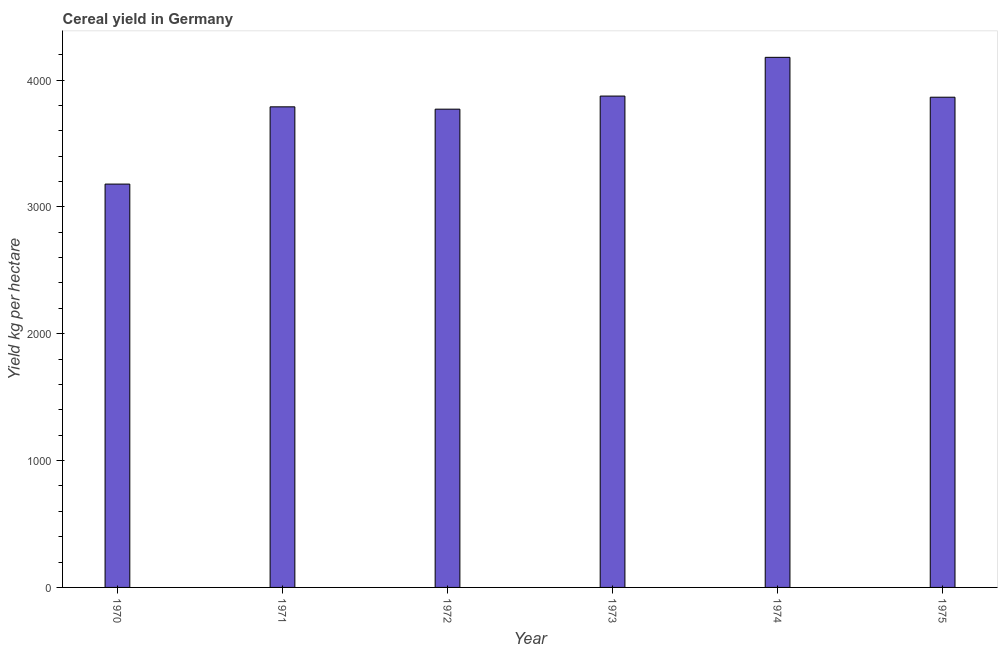Does the graph contain any zero values?
Provide a succinct answer. No. What is the title of the graph?
Give a very brief answer. Cereal yield in Germany. What is the label or title of the Y-axis?
Your answer should be compact. Yield kg per hectare. What is the cereal yield in 1973?
Offer a terse response. 3873.43. Across all years, what is the maximum cereal yield?
Ensure brevity in your answer.  4178.84. Across all years, what is the minimum cereal yield?
Offer a terse response. 3179.65. In which year was the cereal yield maximum?
Make the answer very short. 1974. What is the sum of the cereal yield?
Your answer should be compact. 2.27e+04. What is the difference between the cereal yield in 1972 and 1974?
Your answer should be compact. -408.62. What is the average cereal yield per year?
Offer a very short reply. 3775.86. What is the median cereal yield?
Offer a terse response. 3826.5. In how many years, is the cereal yield greater than 1200 kg per hectare?
Offer a very short reply. 6. Do a majority of the years between 1971 and 1970 (inclusive) have cereal yield greater than 600 kg per hectare?
Ensure brevity in your answer.  No. Is the cereal yield in 1971 less than that in 1975?
Make the answer very short. Yes. Is the difference between the cereal yield in 1970 and 1973 greater than the difference between any two years?
Your response must be concise. No. What is the difference between the highest and the second highest cereal yield?
Give a very brief answer. 305.41. What is the difference between the highest and the lowest cereal yield?
Provide a succinct answer. 999.19. In how many years, is the cereal yield greater than the average cereal yield taken over all years?
Offer a terse response. 4. What is the difference between two consecutive major ticks on the Y-axis?
Make the answer very short. 1000. What is the Yield kg per hectare in 1970?
Provide a succinct answer. 3179.65. What is the Yield kg per hectare in 1971?
Provide a short and direct response. 3788.56. What is the Yield kg per hectare in 1972?
Your answer should be compact. 3770.22. What is the Yield kg per hectare of 1973?
Your answer should be very brief. 3873.43. What is the Yield kg per hectare of 1974?
Keep it short and to the point. 4178.84. What is the Yield kg per hectare in 1975?
Your response must be concise. 3864.43. What is the difference between the Yield kg per hectare in 1970 and 1971?
Ensure brevity in your answer.  -608.91. What is the difference between the Yield kg per hectare in 1970 and 1972?
Your answer should be very brief. -590.57. What is the difference between the Yield kg per hectare in 1970 and 1973?
Your answer should be compact. -693.78. What is the difference between the Yield kg per hectare in 1970 and 1974?
Give a very brief answer. -999.2. What is the difference between the Yield kg per hectare in 1970 and 1975?
Ensure brevity in your answer.  -684.79. What is the difference between the Yield kg per hectare in 1971 and 1972?
Your answer should be very brief. 18.34. What is the difference between the Yield kg per hectare in 1971 and 1973?
Provide a short and direct response. -84.87. What is the difference between the Yield kg per hectare in 1971 and 1974?
Provide a short and direct response. -390.28. What is the difference between the Yield kg per hectare in 1971 and 1975?
Your answer should be very brief. -75.88. What is the difference between the Yield kg per hectare in 1972 and 1973?
Offer a very short reply. -103.21. What is the difference between the Yield kg per hectare in 1972 and 1974?
Your answer should be very brief. -408.62. What is the difference between the Yield kg per hectare in 1972 and 1975?
Offer a terse response. -94.22. What is the difference between the Yield kg per hectare in 1973 and 1974?
Your answer should be compact. -305.41. What is the difference between the Yield kg per hectare in 1973 and 1975?
Keep it short and to the point. 8.99. What is the difference between the Yield kg per hectare in 1974 and 1975?
Offer a very short reply. 314.41. What is the ratio of the Yield kg per hectare in 1970 to that in 1971?
Offer a very short reply. 0.84. What is the ratio of the Yield kg per hectare in 1970 to that in 1972?
Your answer should be compact. 0.84. What is the ratio of the Yield kg per hectare in 1970 to that in 1973?
Provide a short and direct response. 0.82. What is the ratio of the Yield kg per hectare in 1970 to that in 1974?
Make the answer very short. 0.76. What is the ratio of the Yield kg per hectare in 1970 to that in 1975?
Your response must be concise. 0.82. What is the ratio of the Yield kg per hectare in 1971 to that in 1972?
Your answer should be very brief. 1. What is the ratio of the Yield kg per hectare in 1971 to that in 1973?
Keep it short and to the point. 0.98. What is the ratio of the Yield kg per hectare in 1971 to that in 1974?
Offer a very short reply. 0.91. What is the ratio of the Yield kg per hectare in 1971 to that in 1975?
Ensure brevity in your answer.  0.98. What is the ratio of the Yield kg per hectare in 1972 to that in 1973?
Provide a succinct answer. 0.97. What is the ratio of the Yield kg per hectare in 1972 to that in 1974?
Provide a short and direct response. 0.9. What is the ratio of the Yield kg per hectare in 1973 to that in 1974?
Your response must be concise. 0.93. What is the ratio of the Yield kg per hectare in 1973 to that in 1975?
Your answer should be very brief. 1. What is the ratio of the Yield kg per hectare in 1974 to that in 1975?
Ensure brevity in your answer.  1.08. 